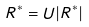<formula> <loc_0><loc_0><loc_500><loc_500>R ^ { \ast } = U | R ^ { \ast } |</formula> 